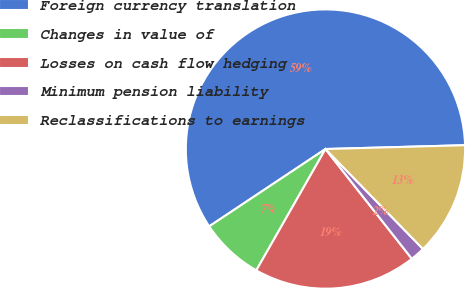Convert chart. <chart><loc_0><loc_0><loc_500><loc_500><pie_chart><fcel>Foreign currency translation<fcel>Changes in value of<fcel>Losses on cash flow hedging<fcel>Minimum pension liability<fcel>Reclassifications to earnings<nl><fcel>58.9%<fcel>7.41%<fcel>18.86%<fcel>1.69%<fcel>13.13%<nl></chart> 